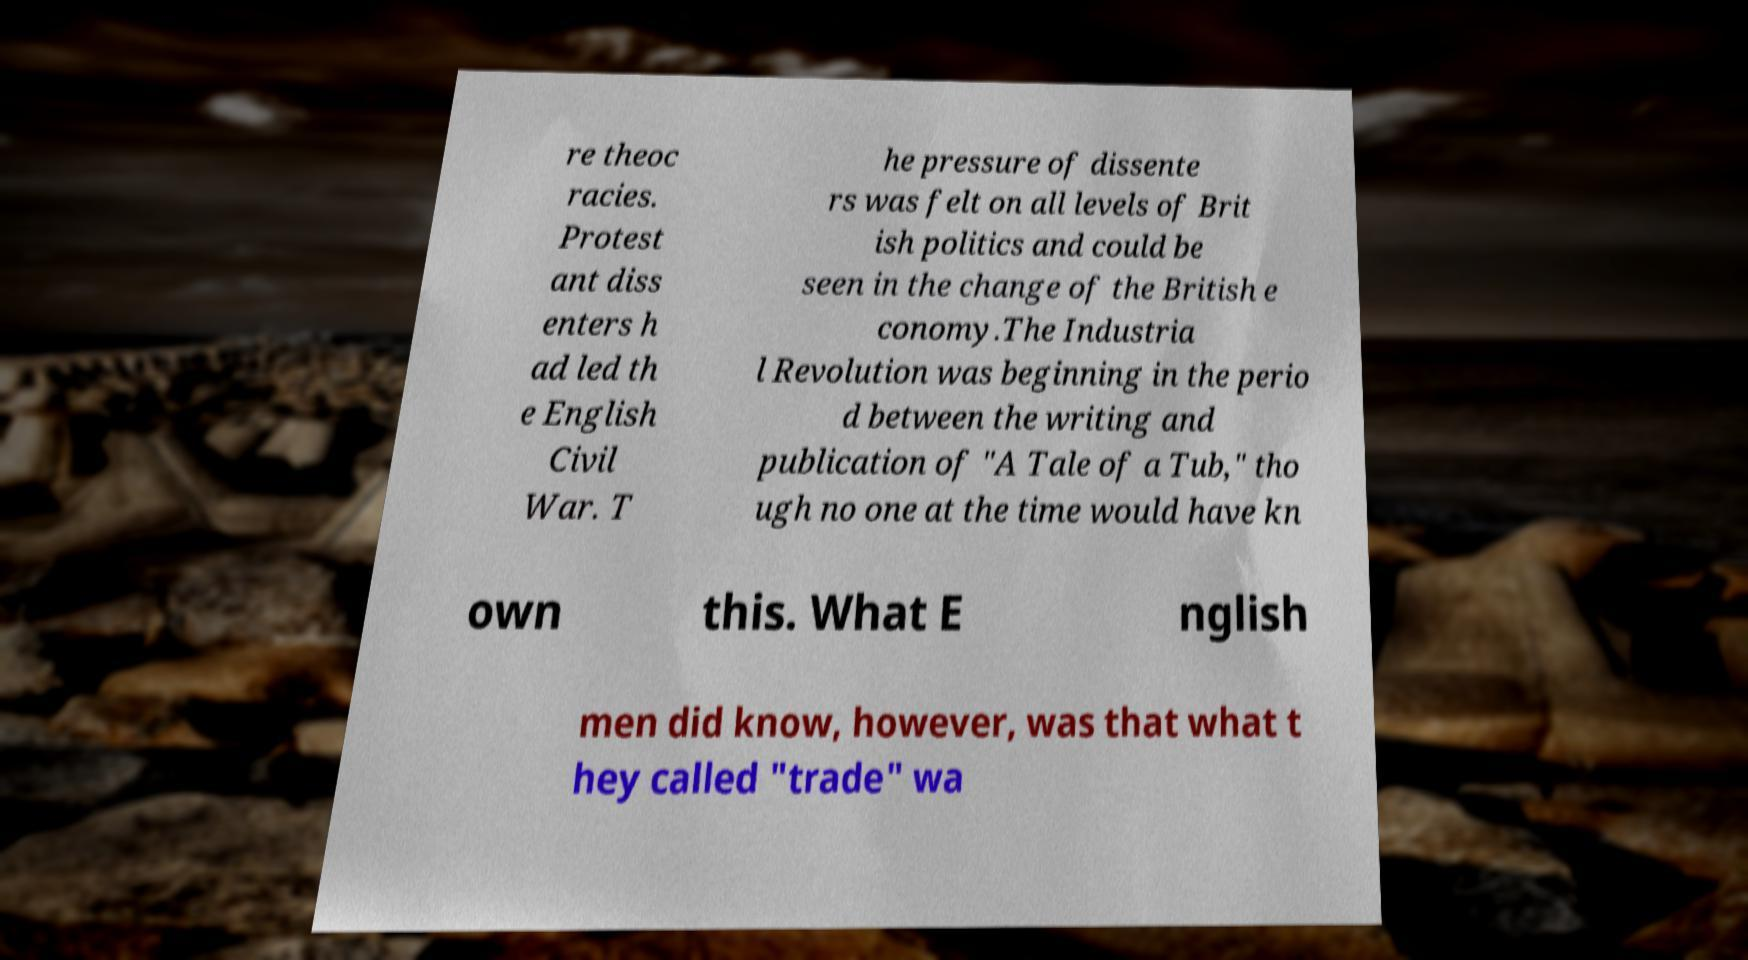There's text embedded in this image that I need extracted. Can you transcribe it verbatim? re theoc racies. Protest ant diss enters h ad led th e English Civil War. T he pressure of dissente rs was felt on all levels of Brit ish politics and could be seen in the change of the British e conomy.The Industria l Revolution was beginning in the perio d between the writing and publication of "A Tale of a Tub," tho ugh no one at the time would have kn own this. What E nglish men did know, however, was that what t hey called "trade" wa 